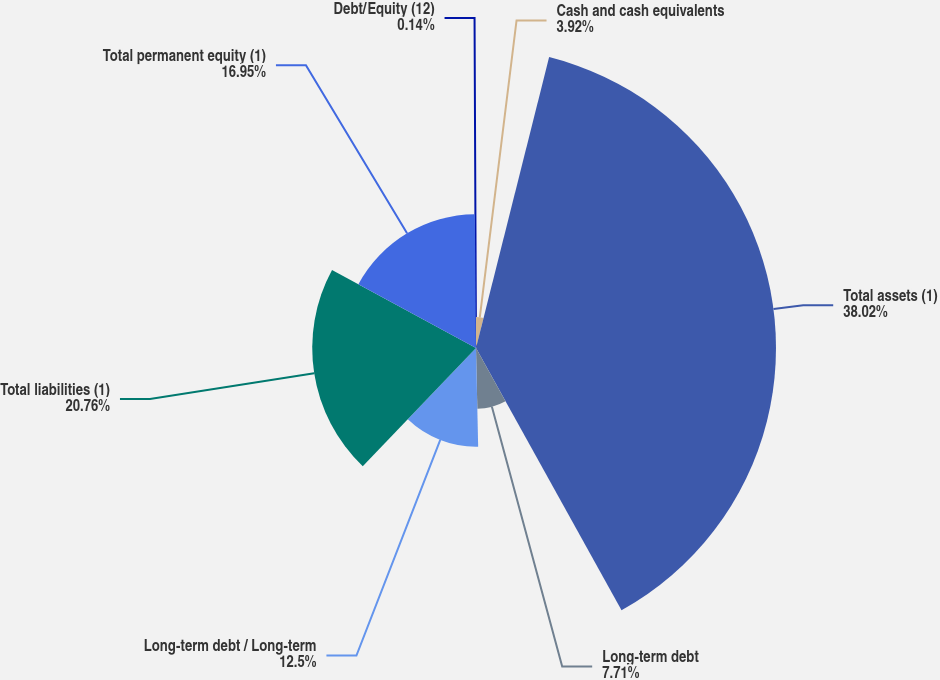Convert chart to OTSL. <chart><loc_0><loc_0><loc_500><loc_500><pie_chart><fcel>Cash and cash equivalents<fcel>Total assets (1)<fcel>Long-term debt<fcel>Long-term debt / Long-term<fcel>Total liabilities (1)<fcel>Total permanent equity (1)<fcel>Debt/Equity (12)<nl><fcel>3.92%<fcel>38.01%<fcel>7.71%<fcel>12.5%<fcel>20.75%<fcel>16.95%<fcel>0.14%<nl></chart> 